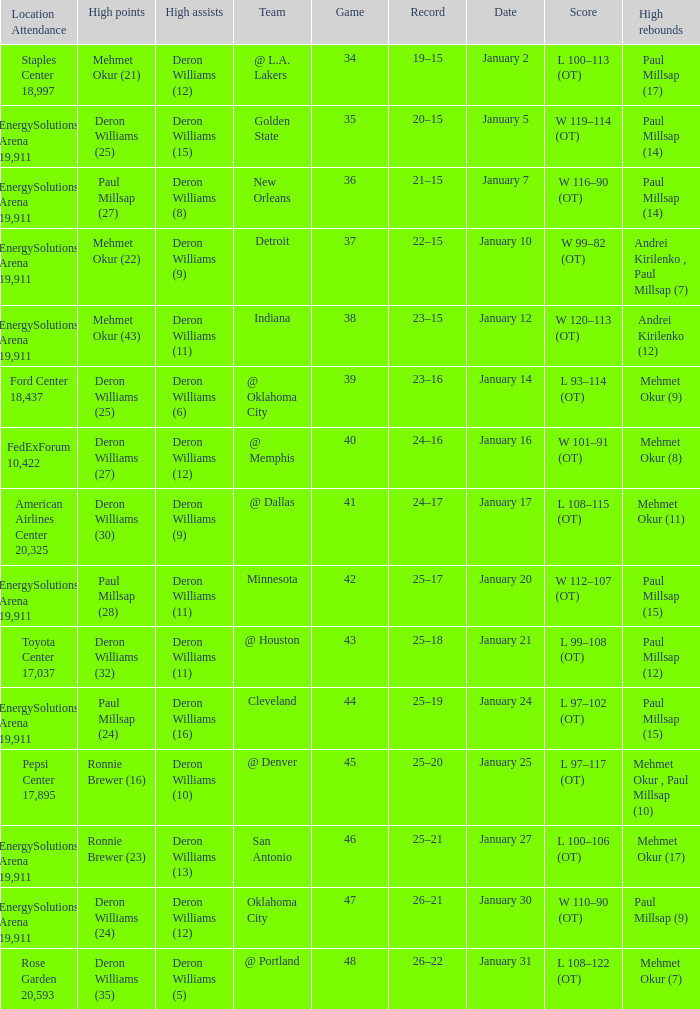Who had the high rebounds on January 24? Paul Millsap (15). 